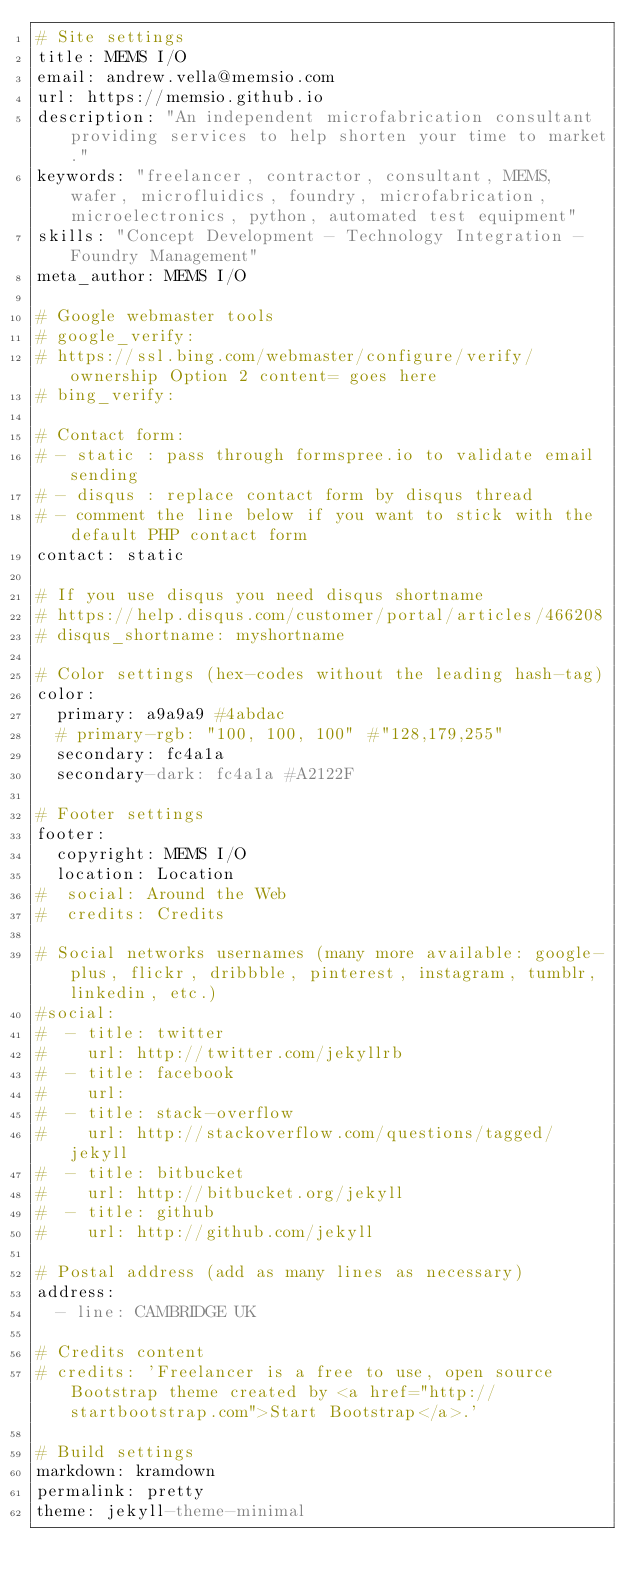Convert code to text. <code><loc_0><loc_0><loc_500><loc_500><_YAML_># Site settings
title: MEMS I/O
email: andrew.vella@memsio.com
url: https://memsio.github.io
description: "An independent microfabrication consultant providing services to help shorten your time to market."
keywords: "freelancer, contractor, consultant, MEMS, wafer, microfluidics, foundry, microfabrication, microelectronics, python, automated test equipment"
skills: "Concept Development - Technology Integration - Foundry Management"
meta_author: MEMS I/O

# Google webmaster tools
# google_verify:
# https://ssl.bing.com/webmaster/configure/verify/ownership Option 2 content= goes here
# bing_verify:

# Contact form:
# - static : pass through formspree.io to validate email sending
# - disqus : replace contact form by disqus thread
# - comment the line below if you want to stick with the default PHP contact form
contact: static

# If you use disqus you need disqus shortname
# https://help.disqus.com/customer/portal/articles/466208
# disqus_shortname: myshortname

# Color settings (hex-codes without the leading hash-tag)
color:
  primary: a9a9a9 #4abdac
  # primary-rgb: "100, 100, 100" #"128,179,255"
  secondary: fc4a1a
  secondary-dark: fc4a1a #A2122F

# Footer settings
footer:
  copyright: MEMS I/O
  location: Location
#  social: Around the Web
#  credits: Credits

# Social networks usernames (many more available: google-plus, flickr, dribbble, pinterest, instagram, tumblr, linkedin, etc.)
#social:
#  - title: twitter
#    url: http://twitter.com/jekyllrb
#  - title: facebook
#    url:
#  - title: stack-overflow
#    url: http://stackoverflow.com/questions/tagged/jekyll
#  - title: bitbucket
#    url: http://bitbucket.org/jekyll
#  - title: github
#    url: http://github.com/jekyll

# Postal address (add as many lines as necessary)
address:
  - line: CAMBRIDGE UK

# Credits content
# credits: 'Freelancer is a free to use, open source Bootstrap theme created by <a href="http://startbootstrap.com">Start Bootstrap</a>.'

# Build settings
markdown: kramdown
permalink: pretty
theme: jekyll-theme-minimal
</code> 